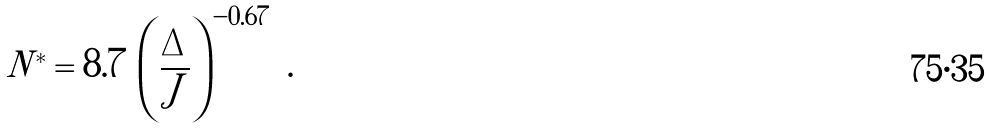Convert formula to latex. <formula><loc_0><loc_0><loc_500><loc_500>N ^ { * } = 8 . 7 \, \left ( \frac { \Delta } { J } \right ) ^ { - 0 . 6 7 } \ .</formula> 